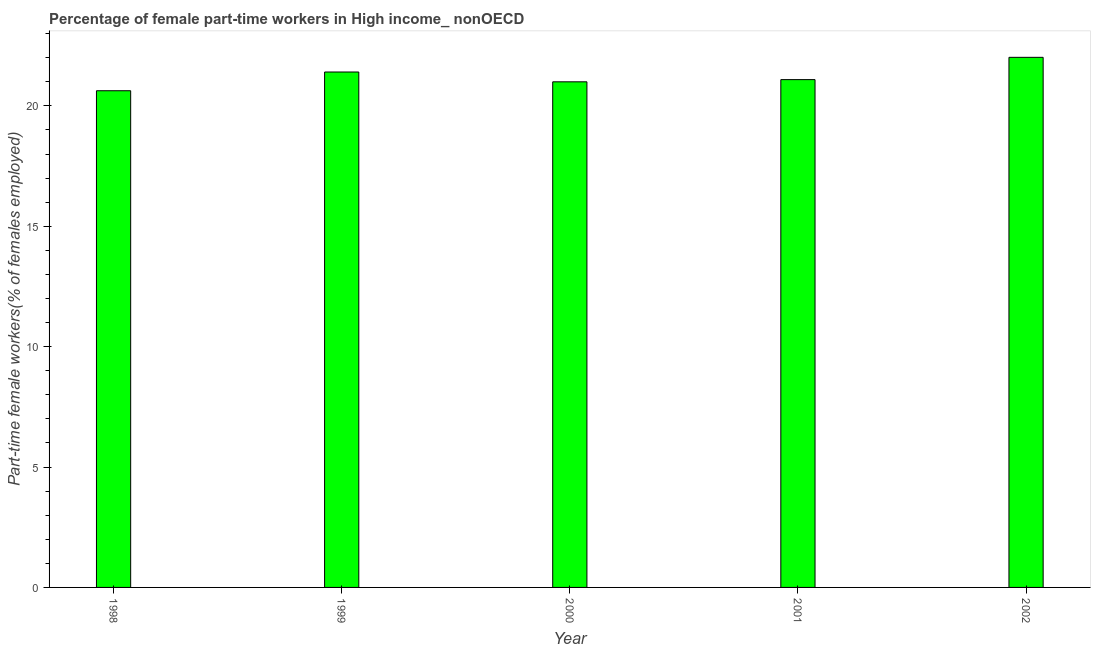Does the graph contain any zero values?
Offer a terse response. No. Does the graph contain grids?
Ensure brevity in your answer.  No. What is the title of the graph?
Offer a terse response. Percentage of female part-time workers in High income_ nonOECD. What is the label or title of the X-axis?
Make the answer very short. Year. What is the label or title of the Y-axis?
Offer a terse response. Part-time female workers(% of females employed). What is the percentage of part-time female workers in 1998?
Make the answer very short. 20.63. Across all years, what is the maximum percentage of part-time female workers?
Your answer should be compact. 22.02. Across all years, what is the minimum percentage of part-time female workers?
Keep it short and to the point. 20.63. In which year was the percentage of part-time female workers maximum?
Make the answer very short. 2002. What is the sum of the percentage of part-time female workers?
Your response must be concise. 106.15. What is the difference between the percentage of part-time female workers in 2000 and 2001?
Provide a short and direct response. -0.09. What is the average percentage of part-time female workers per year?
Your answer should be very brief. 21.23. What is the median percentage of part-time female workers?
Keep it short and to the point. 21.09. Do a majority of the years between 1999 and 2002 (inclusive) have percentage of part-time female workers greater than 15 %?
Your response must be concise. Yes. What is the ratio of the percentage of part-time female workers in 2001 to that in 2002?
Offer a very short reply. 0.96. Is the difference between the percentage of part-time female workers in 2000 and 2001 greater than the difference between any two years?
Provide a succinct answer. No. What is the difference between the highest and the second highest percentage of part-time female workers?
Give a very brief answer. 0.61. What is the difference between the highest and the lowest percentage of part-time female workers?
Give a very brief answer. 1.39. How many bars are there?
Make the answer very short. 5. How many years are there in the graph?
Provide a succinct answer. 5. What is the Part-time female workers(% of females employed) of 1998?
Your answer should be compact. 20.63. What is the Part-time female workers(% of females employed) of 1999?
Your answer should be very brief. 21.41. What is the Part-time female workers(% of females employed) of 2000?
Give a very brief answer. 21. What is the Part-time female workers(% of females employed) of 2001?
Your answer should be compact. 21.09. What is the Part-time female workers(% of females employed) in 2002?
Your answer should be very brief. 22.02. What is the difference between the Part-time female workers(% of females employed) in 1998 and 1999?
Offer a very short reply. -0.78. What is the difference between the Part-time female workers(% of females employed) in 1998 and 2000?
Ensure brevity in your answer.  -0.37. What is the difference between the Part-time female workers(% of females employed) in 1998 and 2001?
Offer a terse response. -0.46. What is the difference between the Part-time female workers(% of females employed) in 1998 and 2002?
Ensure brevity in your answer.  -1.39. What is the difference between the Part-time female workers(% of females employed) in 1999 and 2000?
Keep it short and to the point. 0.41. What is the difference between the Part-time female workers(% of females employed) in 1999 and 2001?
Make the answer very short. 0.32. What is the difference between the Part-time female workers(% of females employed) in 1999 and 2002?
Your response must be concise. -0.61. What is the difference between the Part-time female workers(% of females employed) in 2000 and 2001?
Your answer should be compact. -0.09. What is the difference between the Part-time female workers(% of females employed) in 2000 and 2002?
Your response must be concise. -1.02. What is the difference between the Part-time female workers(% of females employed) in 2001 and 2002?
Make the answer very short. -0.93. What is the ratio of the Part-time female workers(% of females employed) in 1998 to that in 2001?
Offer a very short reply. 0.98. What is the ratio of the Part-time female workers(% of females employed) in 1998 to that in 2002?
Ensure brevity in your answer.  0.94. What is the ratio of the Part-time female workers(% of females employed) in 1999 to that in 2000?
Offer a terse response. 1.02. What is the ratio of the Part-time female workers(% of females employed) in 1999 to that in 2002?
Your answer should be very brief. 0.97. What is the ratio of the Part-time female workers(% of females employed) in 2000 to that in 2002?
Keep it short and to the point. 0.95. What is the ratio of the Part-time female workers(% of females employed) in 2001 to that in 2002?
Make the answer very short. 0.96. 